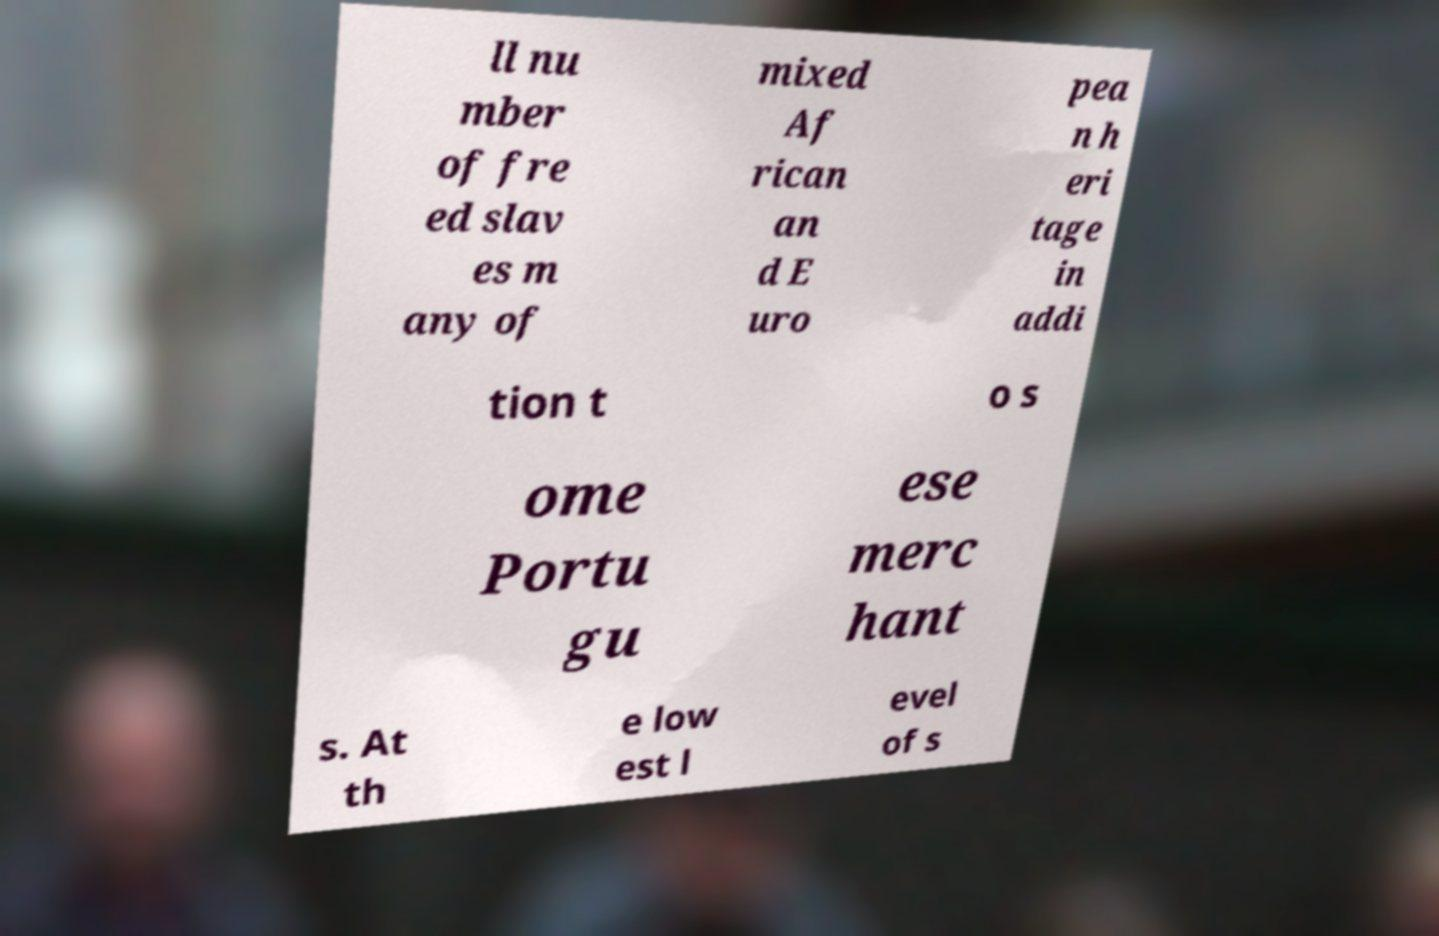Could you extract and type out the text from this image? ll nu mber of fre ed slav es m any of mixed Af rican an d E uro pea n h eri tage in addi tion t o s ome Portu gu ese merc hant s. At th e low est l evel of s 